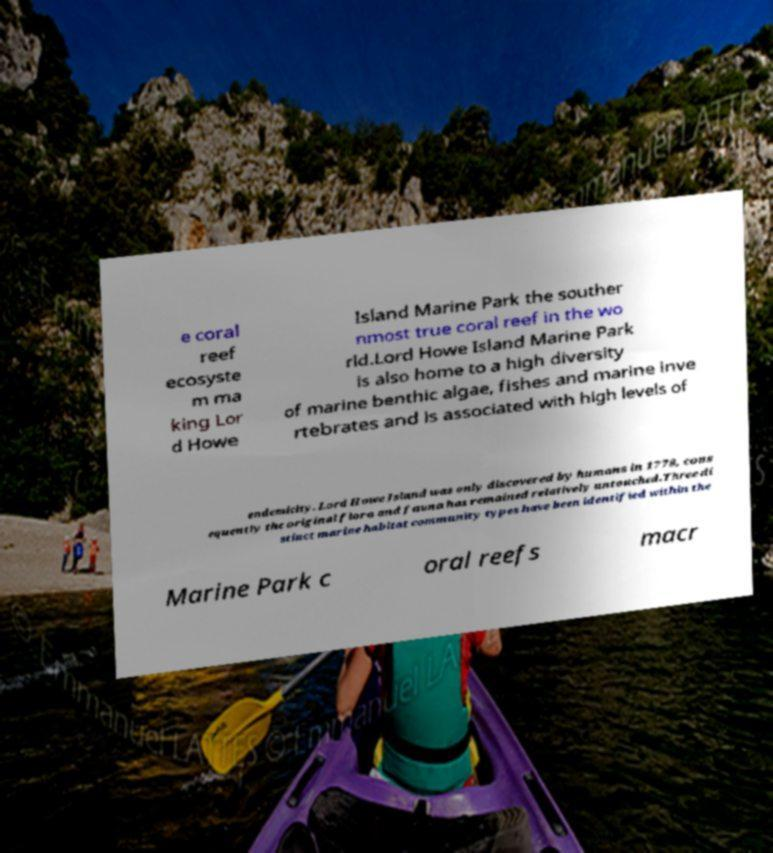For documentation purposes, I need the text within this image transcribed. Could you provide that? e coral reef ecosyste m ma king Lor d Howe Island Marine Park the souther nmost true coral reef in the wo rld.Lord Howe Island Marine Park is also home to a high diversity of marine benthic algae, fishes and marine inve rtebrates and is associated with high levels of endemicity. Lord Howe Island was only discovered by humans in 1778, cons equently the original flora and fauna has remained relatively untouched.Three di stinct marine habitat community types have been identified within the Marine Park c oral reefs macr 